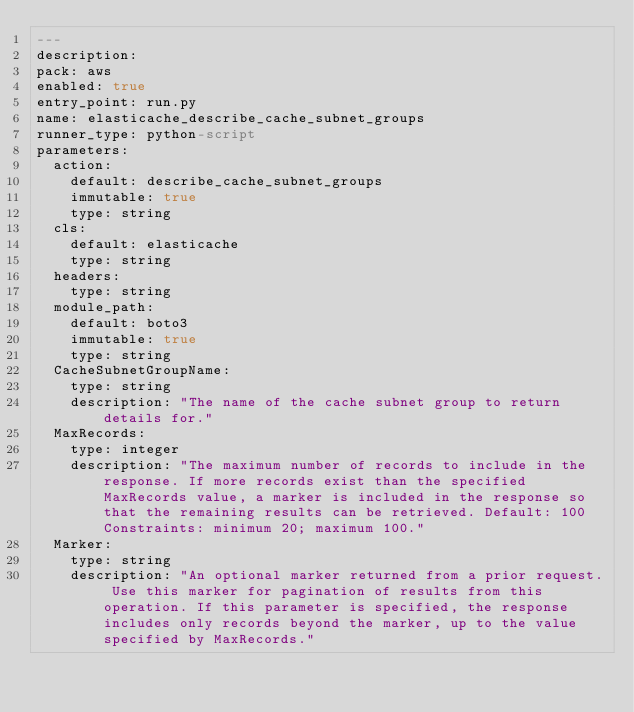<code> <loc_0><loc_0><loc_500><loc_500><_YAML_>---
description: 
pack: aws
enabled: true
entry_point: run.py
name: elasticache_describe_cache_subnet_groups
runner_type: python-script
parameters:
  action:
    default: describe_cache_subnet_groups
    immutable: true
    type: string
  cls:
    default: elasticache
    type: string
  headers:
    type: string
  module_path:
    default: boto3
    immutable: true
    type: string
  CacheSubnetGroupName:
    type: string
    description: "The name of the cache subnet group to return details for."
  MaxRecords:
    type: integer
    description: "The maximum number of records to include in the response. If more records exist than the specified MaxRecords value, a marker is included in the response so that the remaining results can be retrieved. Default: 100 Constraints: minimum 20; maximum 100."
  Marker:
    type: string
    description: "An optional marker returned from a prior request. Use this marker for pagination of results from this operation. If this parameter is specified, the response includes only records beyond the marker, up to the value specified by MaxRecords."</code> 